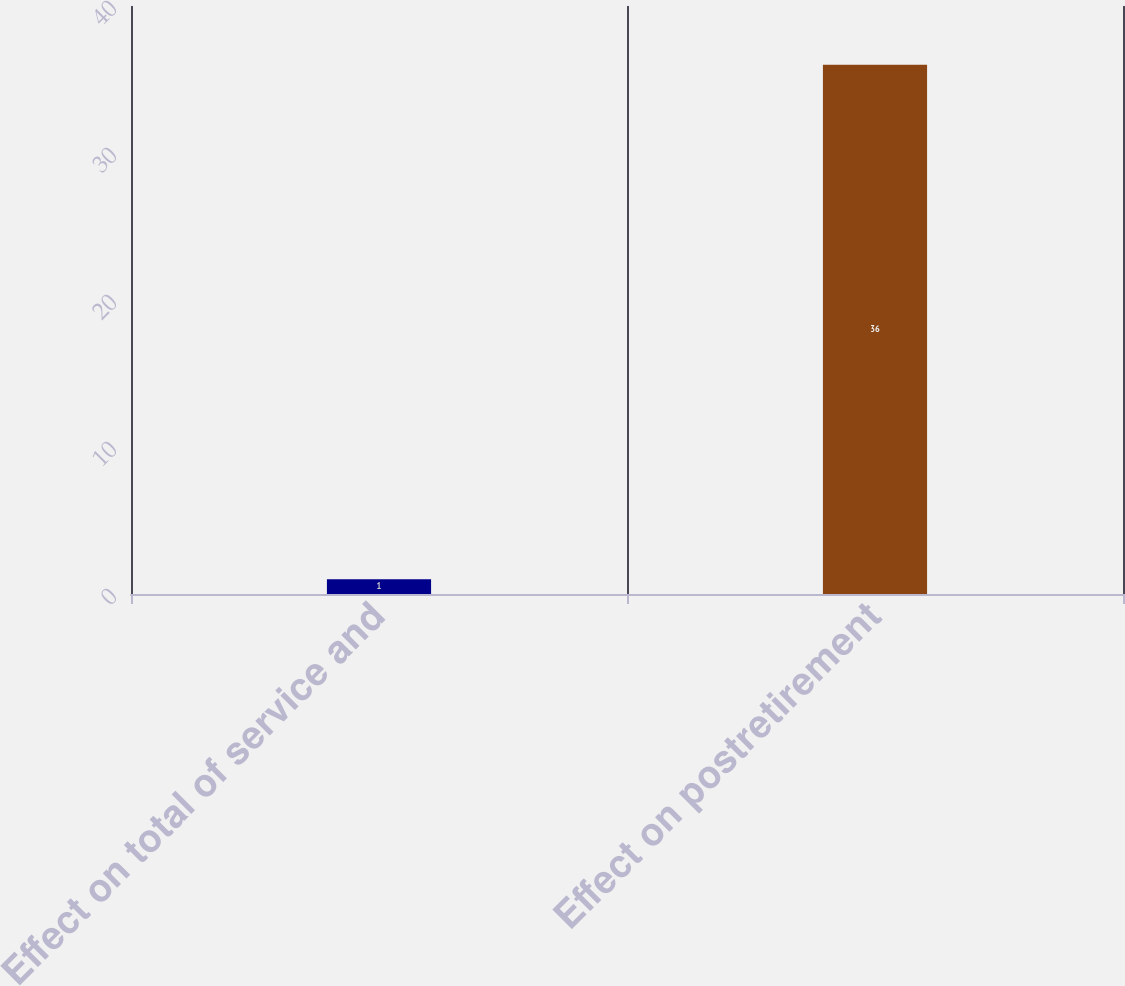Convert chart. <chart><loc_0><loc_0><loc_500><loc_500><bar_chart><fcel>Effect on total of service and<fcel>Effect on postretirement<nl><fcel>1<fcel>36<nl></chart> 